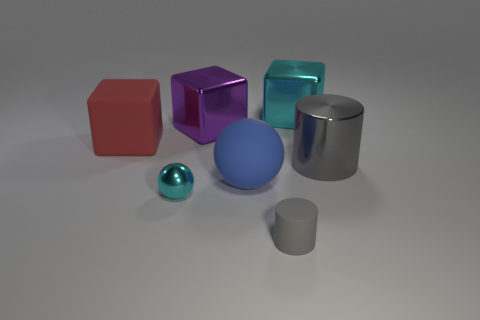There is a gray thing in front of the small metallic ball; how many big blue objects are to the right of it?
Ensure brevity in your answer.  0. Is the gray cylinder that is behind the tiny matte object made of the same material as the large ball?
Your answer should be very brief. No. Is the material of the cylinder that is in front of the large metallic cylinder the same as the cyan object that is in front of the large metal cylinder?
Your answer should be very brief. No. Are there more blue matte objects in front of the large red block than large purple rubber objects?
Your response must be concise. Yes. There is a small thing that is on the left side of the rubber object in front of the large rubber ball; what is its color?
Offer a terse response. Cyan. The cyan object that is the same size as the purple shiny cube is what shape?
Offer a terse response. Cube. What is the shape of the big thing that is the same color as the small shiny ball?
Your answer should be compact. Cube. Are there the same number of tiny cyan metallic things that are behind the big red rubber thing and tiny yellow rubber objects?
Offer a very short reply. Yes. There is a small thing that is behind the gray object that is on the left side of the metal object right of the large cyan cube; what is it made of?
Ensure brevity in your answer.  Metal. There is a purple object that is the same material as the tiny cyan ball; what shape is it?
Give a very brief answer. Cube. 